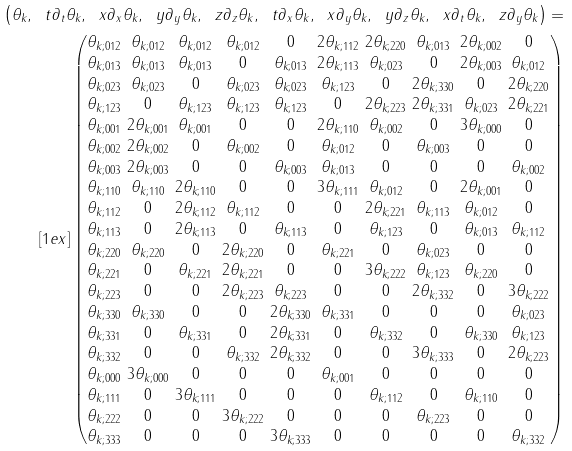Convert formula to latex. <formula><loc_0><loc_0><loc_500><loc_500>\left ( \theta _ { k } , \ t \partial _ { t } \theta _ { k } , \ x \partial _ { x } \theta _ { k } , \ y \partial _ { y } \theta _ { k } , \ z \partial _ { z } \theta _ { k } , \ t \partial _ { x } \theta _ { k } , \ x \partial _ { y } \theta _ { k } , \ y \partial _ { z } \theta _ { k } , \ x \partial _ { t } \theta _ { k } , \ z \partial _ { y } \theta _ { k } \right ) = \\ [ 1 e x ] \begin{pmatrix} \begin{matrix} \theta _ { k ; 0 1 2 } \\ \theta _ { k ; 0 1 3 } \\ \theta _ { k ; 0 2 3 } \\ \theta _ { k ; 1 2 3 } \\ \theta _ { k ; 0 0 1 } \\ \theta _ { k ; 0 0 2 } \\ \theta _ { k ; 0 0 3 } \\ \theta _ { k ; 1 1 0 } \\ \theta _ { k ; 1 1 2 } \\ \theta _ { k ; 1 1 3 } \\ \theta _ { k ; 2 2 0 } \\ \theta _ { k ; 2 2 1 } \\ \theta _ { k ; 2 2 3 } \\ \theta _ { k ; 3 3 0 } \\ \theta _ { k ; 3 3 1 } \\ \theta _ { k ; 3 3 2 } \\ \theta _ { k ; 0 0 0 } \\ \theta _ { k ; 1 1 1 } \\ \theta _ { k ; 2 2 2 } \\ \theta _ { k ; 3 3 3 } \end{matrix} \ \begin{matrix} \theta _ { k ; 0 1 2 } \\ \theta _ { k ; 0 1 3 } \\ \theta _ { k ; 0 2 3 } \\ 0 \\ 2 \theta _ { k ; 0 0 1 } \\ 2 \theta _ { k ; 0 0 2 } \\ 2 \theta _ { k ; 0 0 3 } \\ \theta _ { k ; 1 1 0 } \\ 0 \\ 0 \\ \theta _ { k ; 2 2 0 } \\ 0 \\ 0 \\ \theta _ { k ; 3 3 0 } \\ 0 \\ 0 \\ 3 \theta _ { k ; 0 0 0 } \\ 0 \\ 0 \\ 0 \end{matrix} \ \begin{matrix} \theta _ { k ; 0 1 2 } \\ \theta _ { k ; 0 1 3 } \\ 0 \\ \theta _ { k ; 1 2 3 } \\ \theta _ { k ; 0 0 1 } \\ 0 \\ 0 \\ 2 \theta _ { k ; 1 1 0 } \\ 2 \theta _ { k ; 1 1 2 } \\ 2 \theta _ { k ; 1 1 3 } \\ 0 \\ \theta _ { k ; 2 2 1 } \\ 0 \\ 0 \\ \theta _ { k ; 3 3 1 } \\ 0 \\ 0 \\ 3 \theta _ { k ; 1 1 1 } \\ 0 \\ 0 \end{matrix} \ \begin{matrix} \theta _ { k ; 0 1 2 } \\ 0 \\ \theta _ { k ; 0 2 3 } \\ \theta _ { k ; 1 2 3 } \\ 0 \\ \theta _ { k ; 0 0 2 } \\ 0 \\ 0 \\ \theta _ { k ; 1 1 2 } \\ 0 \\ 2 \theta _ { k ; 2 2 0 } \\ 2 \theta _ { k ; 2 2 1 } \\ 2 \theta _ { k ; 2 2 3 } \\ 0 \\ 0 \\ \theta _ { k ; 3 3 2 } \\ 0 \\ 0 \\ 3 \theta _ { k ; 2 2 2 } \\ 0 \end{matrix} \ \begin{matrix} 0 \\ \theta _ { k ; 0 1 3 } \\ \theta _ { k ; 0 2 3 } \\ \theta _ { k ; 1 2 3 } \\ 0 \\ 0 \\ \theta _ { k ; 0 0 3 } \\ 0 \\ 0 \\ \theta _ { k ; 1 1 3 } \\ 0 \\ 0 \\ \theta _ { k ; 2 2 3 } \\ 2 \theta _ { k ; 3 3 0 } \\ 2 \theta _ { k ; 3 3 1 } \\ 2 \theta _ { k ; 3 3 2 } \\ 0 \\ 0 \\ 0 \\ 3 \theta _ { k ; 3 3 3 } \end{matrix} \ \begin{matrix} 2 \theta _ { k ; 1 1 2 } \\ 2 \theta _ { k ; 1 1 3 } \\ \theta _ { k ; 1 2 3 } \\ 0 \\ 2 \theta _ { k ; 1 1 0 } \\ \theta _ { k ; 0 1 2 } \\ \theta _ { k ; 0 1 3 } \\ 3 \theta _ { k ; 1 1 1 } \\ 0 \\ 0 \\ \theta _ { k ; 2 2 1 } \\ 0 \\ 0 \\ \theta _ { k ; 3 3 1 } \\ 0 \\ 0 \\ \theta _ { k ; 0 0 1 } \\ 0 \\ 0 \\ 0 \end{matrix} \ \begin{matrix} 2 \theta _ { k ; 2 2 0 } \\ \theta _ { k ; 0 2 3 } \\ 0 \\ 2 \theta _ { k ; 2 2 3 } \\ \theta _ { k ; 0 0 2 } \\ 0 \\ 0 \\ \theta _ { k ; 0 1 2 } \\ 2 \theta _ { k ; 2 2 1 } \\ \theta _ { k ; 1 2 3 } \\ 0 \\ 3 \theta _ { k ; 2 2 2 } \\ 0 \\ 0 \\ \theta _ { k ; 3 3 2 } \\ 0 \\ 0 \\ \theta _ { k ; 1 1 2 } \\ 0 \\ 0 \end{matrix} \ \begin{matrix} \theta _ { k ; 0 1 3 } \\ 0 \\ 2 \theta _ { k ; 3 3 0 } \\ 2 \theta _ { k ; 3 3 1 } \\ 0 \\ \theta _ { k ; 0 0 3 } \\ 0 \\ 0 \\ \theta _ { k ; 1 1 3 } \\ 0 \\ \theta _ { k ; 0 2 3 } \\ \theta _ { k ; 1 2 3 } \\ 2 \theta _ { k ; 3 3 2 } \\ 0 \\ 0 \\ 3 \theta _ { k ; 3 3 3 } \\ 0 \\ 0 \\ \theta _ { k ; 2 2 3 } \\ 0 \end{matrix} \ \begin{matrix} 2 \theta _ { k ; 0 0 2 } \\ 2 \theta _ { k ; 0 0 3 } \\ 0 \\ \theta _ { k ; 0 2 3 } \\ 3 \theta _ { k ; 0 0 0 } \\ 0 \\ 0 \\ 2 \theta _ { k ; 0 0 1 } \\ \theta _ { k ; 0 1 2 } \\ \theta _ { k ; 0 1 3 } \\ 0 \\ \theta _ { k ; 2 2 0 } \\ 0 \\ 0 \\ \theta _ { k ; 3 3 0 } \\ 0 \\ 0 \\ \theta _ { k ; 1 1 0 } \\ 0 \\ 0 \end{matrix} \ \begin{matrix} 0 \\ \theta _ { k ; 0 1 2 } \\ 2 \theta _ { k ; 2 2 0 } \\ 2 \theta _ { k ; 2 2 1 } \\ 0 \\ 0 \\ \theta _ { k ; 0 0 2 } \\ 0 \\ 0 \\ \theta _ { k ; 1 1 2 } \\ 0 \\ 0 \\ 3 \theta _ { k ; 2 2 2 } \\ \theta _ { k ; 0 2 3 } \\ \theta _ { k ; 1 2 3 } \\ 2 \theta _ { k ; 2 2 3 } \\ 0 \\ 0 \\ 0 \\ \theta _ { k ; 3 3 2 } \end{matrix} \end{pmatrix}</formula> 